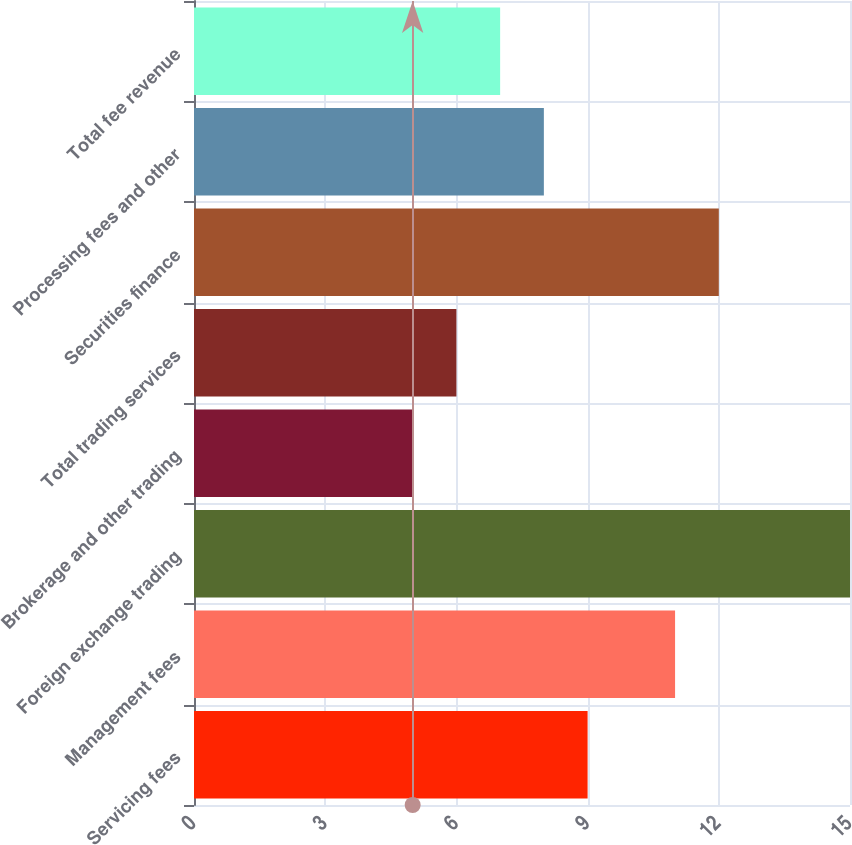Convert chart to OTSL. <chart><loc_0><loc_0><loc_500><loc_500><bar_chart><fcel>Servicing fees<fcel>Management fees<fcel>Foreign exchange trading<fcel>Brokerage and other trading<fcel>Total trading services<fcel>Securities finance<fcel>Processing fees and other<fcel>Total fee revenue<nl><fcel>9<fcel>11<fcel>15<fcel>5<fcel>6<fcel>12<fcel>8<fcel>7<nl></chart> 